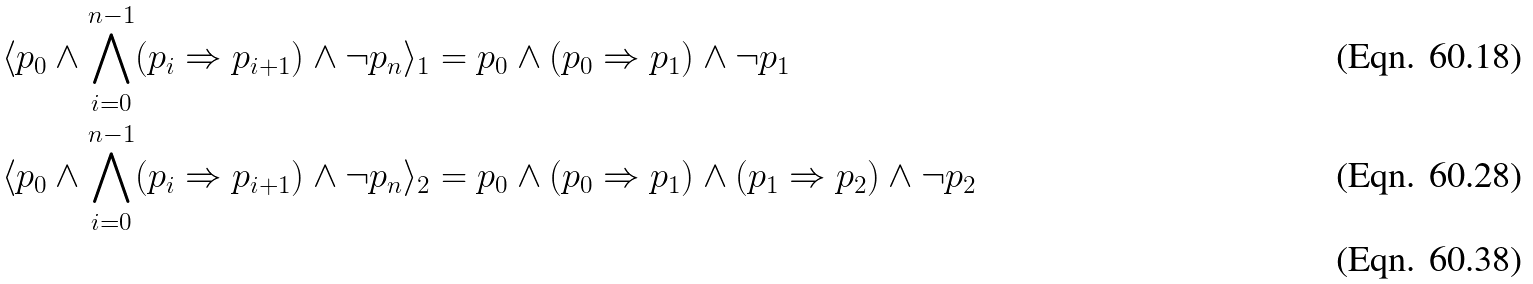<formula> <loc_0><loc_0><loc_500><loc_500>\langle p _ { 0 } \land \bigwedge _ { i = 0 } ^ { n - 1 } ( p _ { i } \Rightarrow p _ { i + 1 } ) \land \neg p _ { n } \rangle _ { 1 } & = p _ { 0 } \land ( p _ { 0 } \Rightarrow p _ { 1 } ) \land \neg p _ { 1 } \\ \langle p _ { 0 } \land \bigwedge _ { i = 0 } ^ { n - 1 } ( p _ { i } \Rightarrow p _ { i + 1 } ) \land \neg p _ { n } \rangle _ { 2 } & = p _ { 0 } \land ( p _ { 0 } \Rightarrow p _ { 1 } ) \land ( p _ { 1 } \Rightarrow p _ { 2 } ) \land \neg p _ { 2 } \\</formula> 